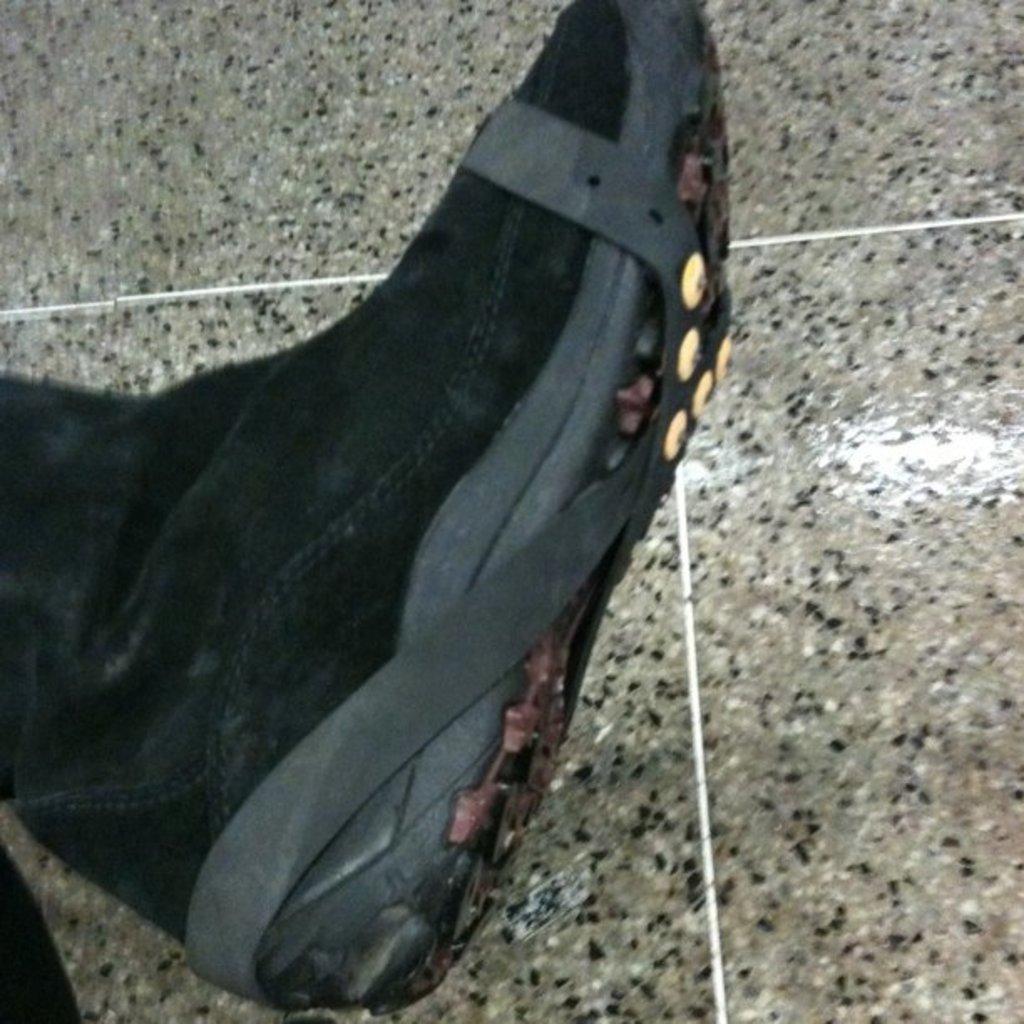Could you give a brief overview of what you see in this image? In this image I can see the shoe which is in black color. It is on the floor which is in black and ash color. 